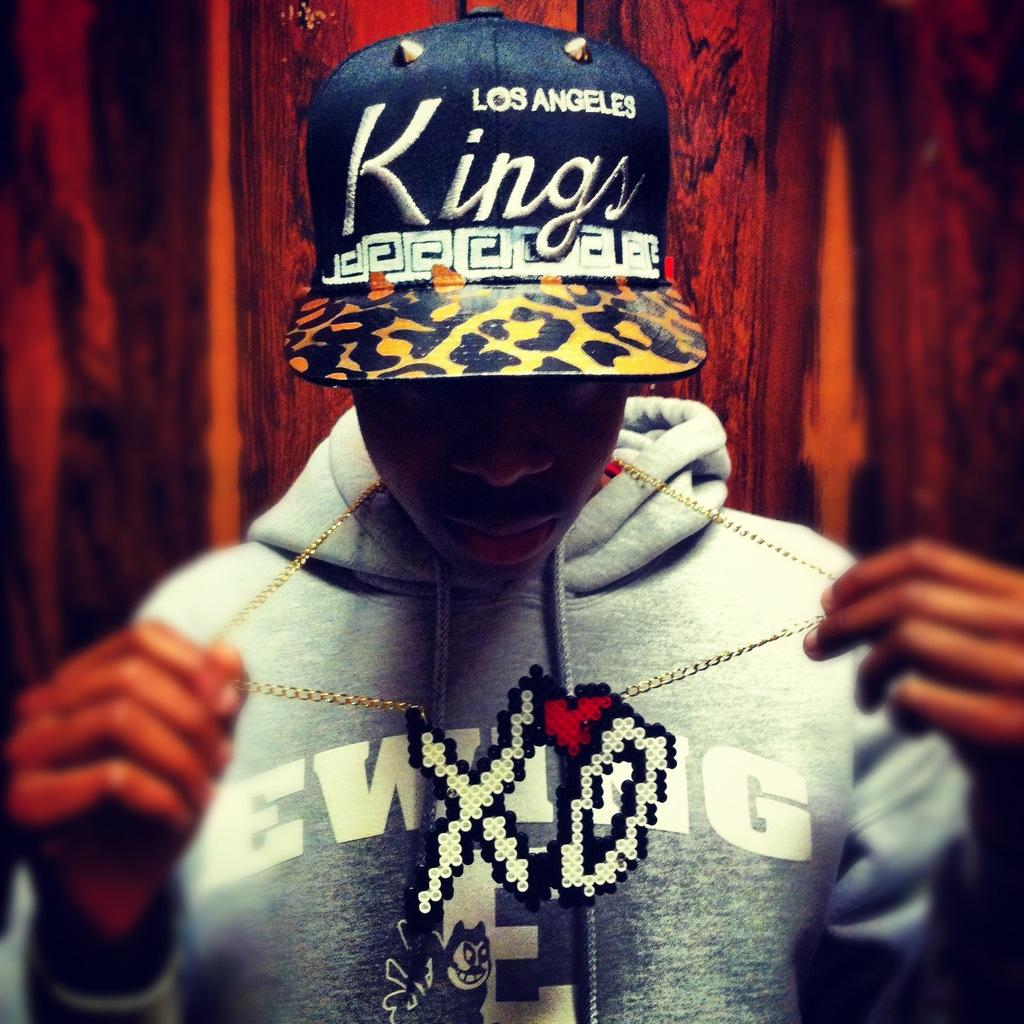Who is the main subject in the image? There is a boy in the image. What is the boy wearing on his upper body? The boy is wearing a sweater. What type of headwear is the boy wearing? The boy is wearing a black color cap. What type of tray is the boy holding in the image? There is no tray present in the image; the boy is not holding anything. 